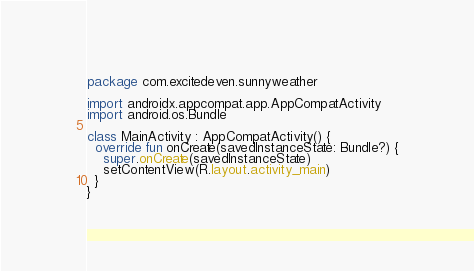Convert code to text. <code><loc_0><loc_0><loc_500><loc_500><_Kotlin_>package com.excitedeven.sunnyweather

import androidx.appcompat.app.AppCompatActivity
import android.os.Bundle

class MainActivity : AppCompatActivity() {
  override fun onCreate(savedInstanceState: Bundle?) {
    super.onCreate(savedInstanceState)
    setContentView(R.layout.activity_main)
  }
}</code> 